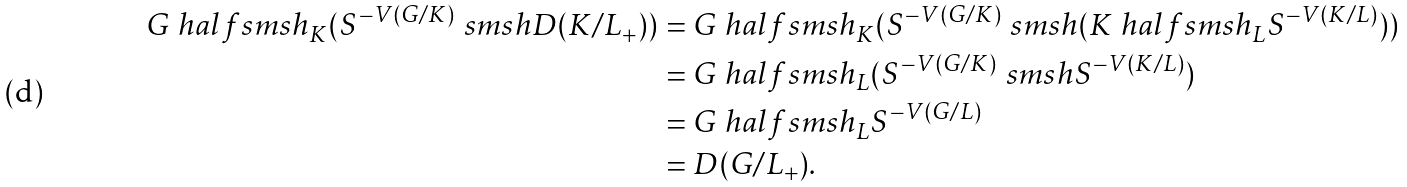<formula> <loc_0><loc_0><loc_500><loc_500>G \ h a l f s m s h _ { K } ( S ^ { - V ( G / K ) } \ s m s h D ( K / L _ { + } ) ) & = G \ h a l f s m s h _ { K } ( S ^ { - V ( G / K ) } \ s m s h ( K \ h a l f s m s h _ { L } S ^ { - V ( K / L ) } ) ) \\ & = G \ h a l f s m s h _ { L } ( S ^ { - V ( G / K ) } \ s m s h S ^ { - V ( K / L ) } ) \\ & = G \ h a l f s m s h _ { L } S ^ { - V ( G / L ) } \\ & = D ( G / L _ { + } ) .</formula> 